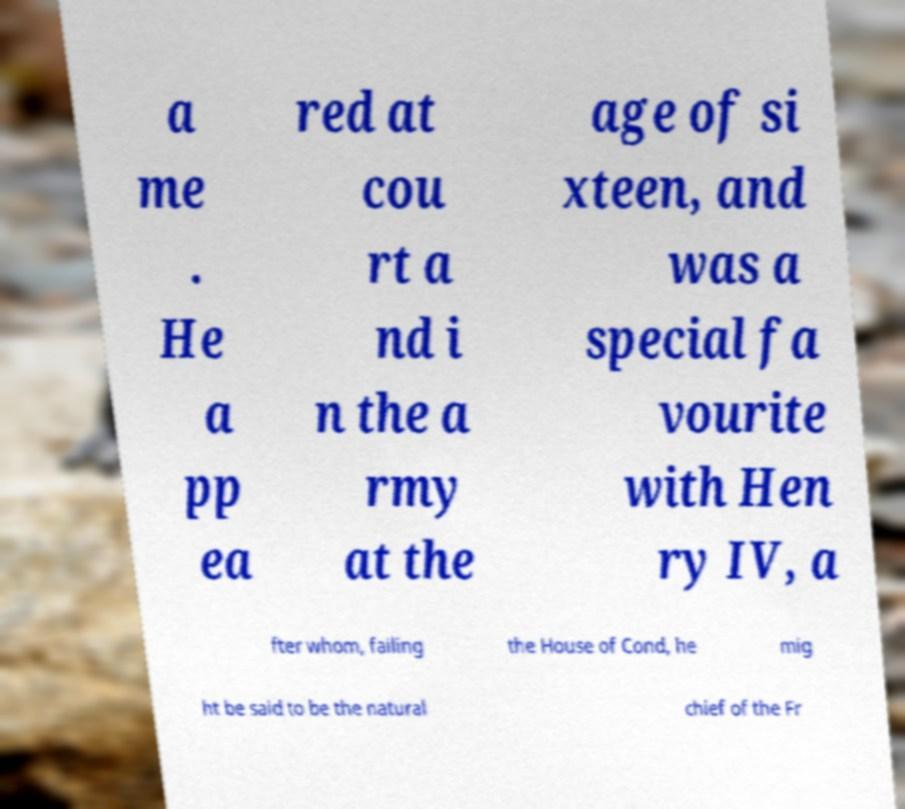Please identify and transcribe the text found in this image. a me . He a pp ea red at cou rt a nd i n the a rmy at the age of si xteen, and was a special fa vourite with Hen ry IV, a fter whom, failing the House of Cond, he mig ht be said to be the natural chief of the Fr 